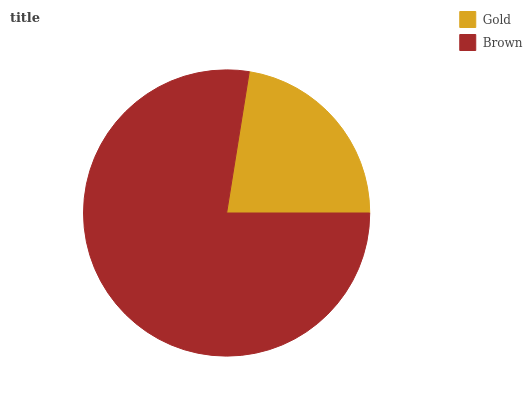Is Gold the minimum?
Answer yes or no. Yes. Is Brown the maximum?
Answer yes or no. Yes. Is Brown the minimum?
Answer yes or no. No. Is Brown greater than Gold?
Answer yes or no. Yes. Is Gold less than Brown?
Answer yes or no. Yes. Is Gold greater than Brown?
Answer yes or no. No. Is Brown less than Gold?
Answer yes or no. No. Is Brown the high median?
Answer yes or no. Yes. Is Gold the low median?
Answer yes or no. Yes. Is Gold the high median?
Answer yes or no. No. Is Brown the low median?
Answer yes or no. No. 